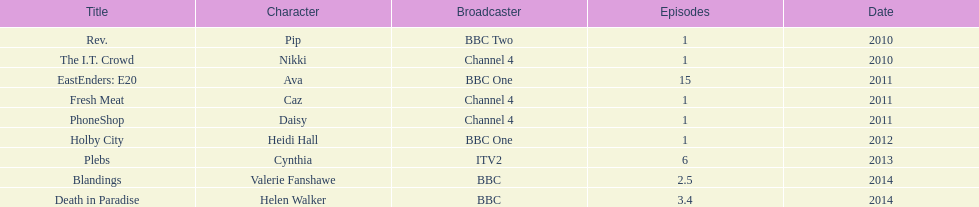Which broadcaster hosted 3 titles but they had only 1 episode? Channel 4. 